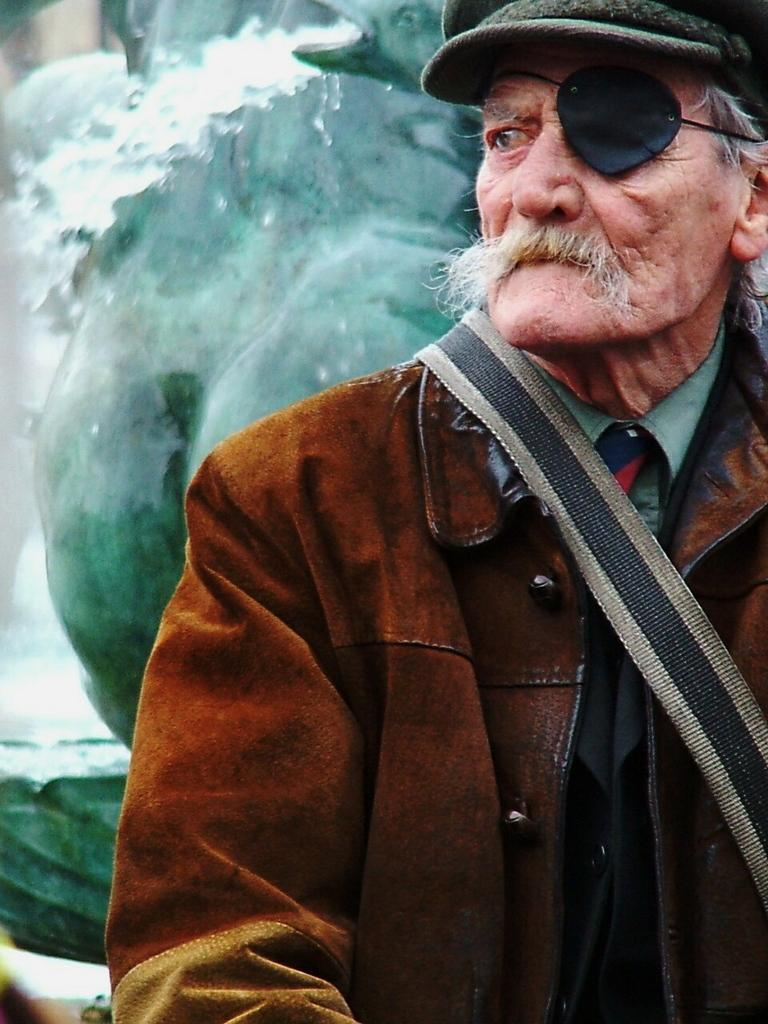Who or what is present in the image? There is a person in the image. What is the person wearing on their head? The person is wearing a cap. What type of clothing is the person wearing on their upper body? The person is wearing a jacket. What can be seen in the background of the image? There is a fountain in the background of the image. What type of van can be seen parked next to the fountain in the image? There is no van present in the image; only a person and a fountain are visible. What is the person using to hammer nails into the ground in the image? There is no hammer or any activity involving nails in the image. 